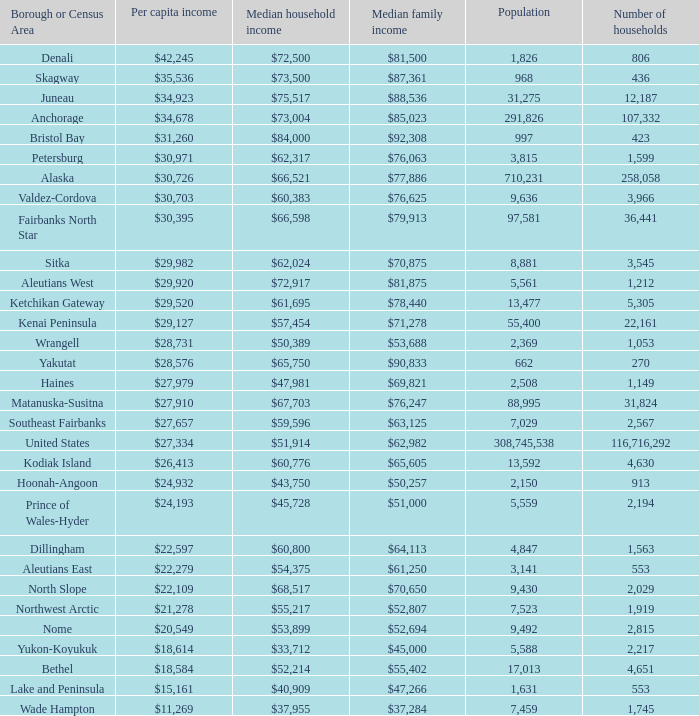What is the population of the zone with a median family income of $71,278? 1.0. 